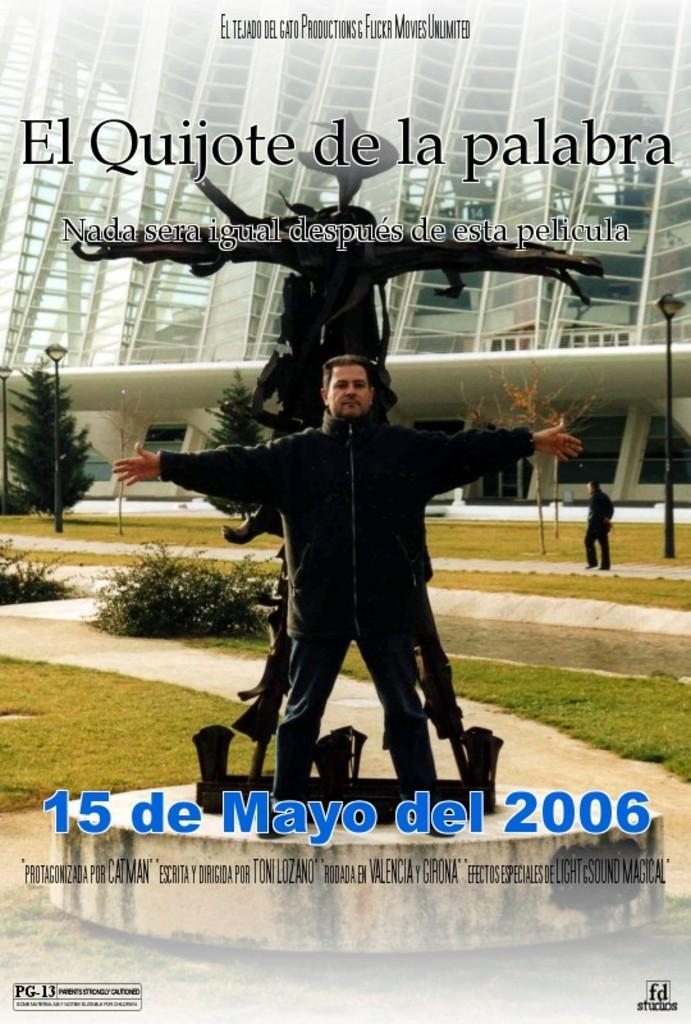<image>
Render a clear and concise summary of the photo. A person standing in front of a statue the says El Quijote de la palabra. 